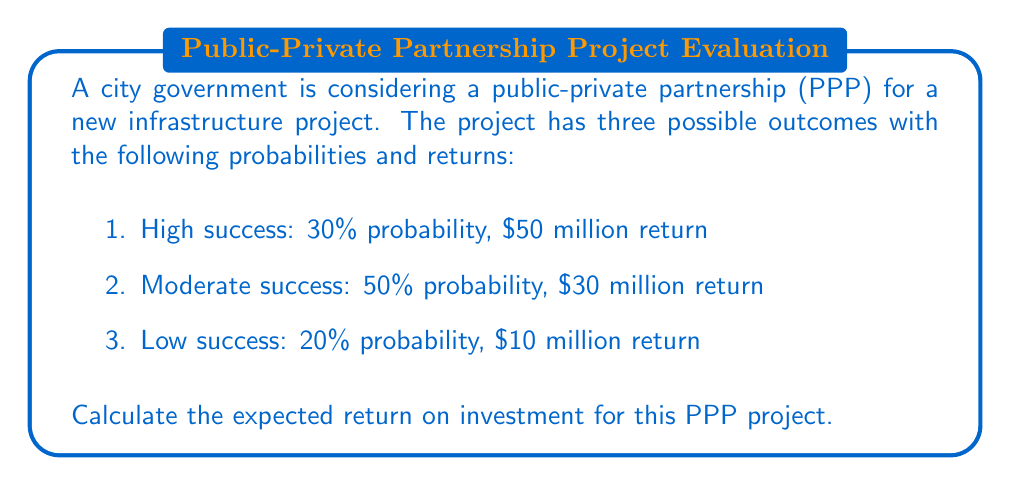Give your solution to this math problem. To calculate the expected return on investment for this public-private partnership project, we need to use the concept of expected value for a discrete random variable. The expected value is the sum of each possible outcome multiplied by its probability.

Let's define our random variable X as the return on investment. We can calculate the expected value E(X) as follows:

$$E(X) = \sum_{i=1}^{n} x_i \cdot p(x_i)$$

Where:
$x_i$ is the return for each outcome
$p(x_i)$ is the probability of each outcome

Step 1: Calculate the contribution of each outcome to the expected value:

1. High success: $50 \text{ million} \cdot 0.30 = 15 \text{ million}$
2. Moderate success: $30 \text{ million} \cdot 0.50 = 15 \text{ million}$
3. Low success: $10 \text{ million} \cdot 0.20 = 2 \text{ million}$

Step 2: Sum up all the contributions:

$$E(X) = 15 + 15 + 2 = 32 \text{ million}$$

Therefore, the expected return on investment for this PPP project is $32 million.
Answer: $32 million 